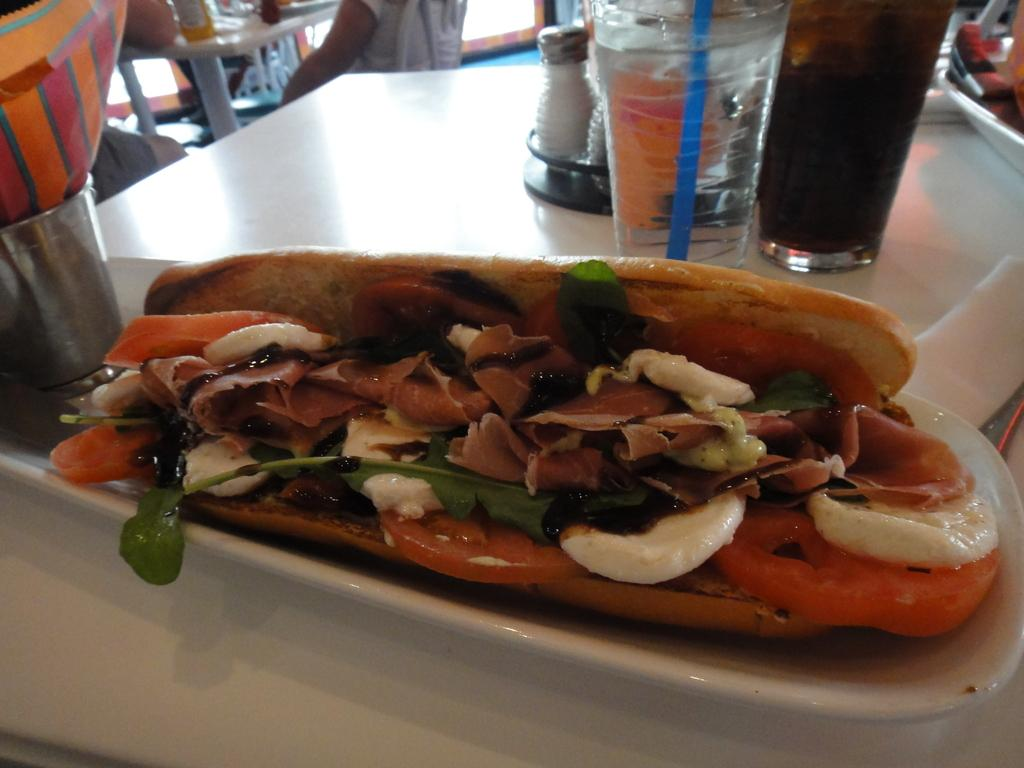What piece of furniture is present in the image? There is a table in the image. What objects are placed on the table? There are glasses, sprinklers, and a plate on the table. What is on the plate? There is food placed on the table. Are there any people visible in the image? Yes, there are people sitting in the background of the image. What type of band is playing in the image? There is no band present in the image. Can you describe the thumb of the person sitting in the background? There is no thumb visible in the image, as the people are sitting in the background and not shown in detail. 